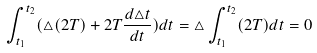<formula> <loc_0><loc_0><loc_500><loc_500>\int _ { t _ { 1 } } ^ { t _ { 2 } } ( \triangle ( 2 T ) + 2 T \frac { d \triangle t } { d t } ) d t = \triangle \int _ { t _ { 1 } } ^ { t _ { 2 } } ( 2 T ) d t = 0</formula> 